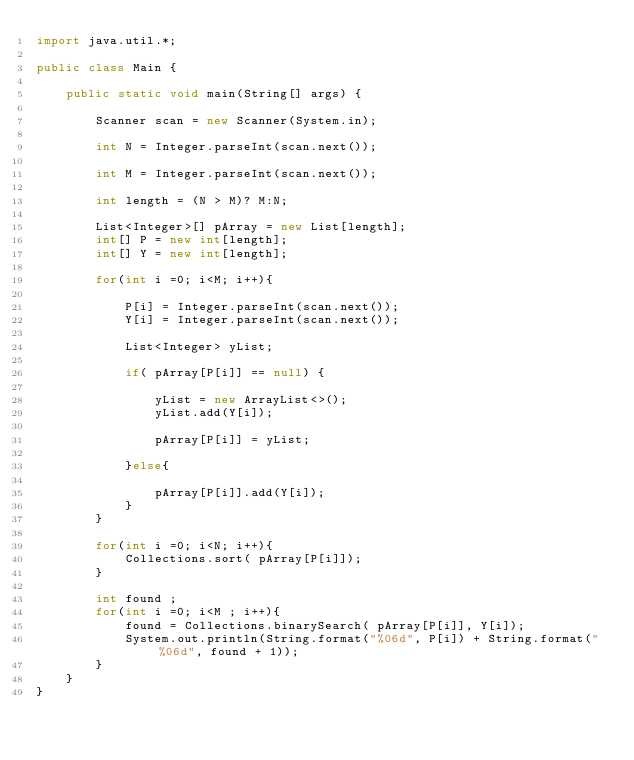Convert code to text. <code><loc_0><loc_0><loc_500><loc_500><_Java_>import java.util.*;

public class Main {

    public static void main(String[] args) {

        Scanner scan = new Scanner(System.in);

        int N = Integer.parseInt(scan.next());

        int M = Integer.parseInt(scan.next());

        int length = (N > M)? M:N;

        List<Integer>[] pArray = new List[length];
        int[] P = new int[length];
        int[] Y = new int[length];

        for(int i =0; i<M; i++){

            P[i] = Integer.parseInt(scan.next());
            Y[i] = Integer.parseInt(scan.next());

            List<Integer> yList;

            if( pArray[P[i]] == null) {
                
                yList = new ArrayList<>();
                yList.add(Y[i]);
                
                pArray[P[i]] = yList;
                
            }else{
                
                pArray[P[i]].add(Y[i]);
            }
        }

        for(int i =0; i<N; i++){
            Collections.sort( pArray[P[i]]);
        }

        int found ;
        for(int i =0; i<M ; i++){
            found = Collections.binarySearch( pArray[P[i]], Y[i]);
            System.out.println(String.format("%06d", P[i]) + String.format("%06d", found + 1));
        }
    }
}</code> 